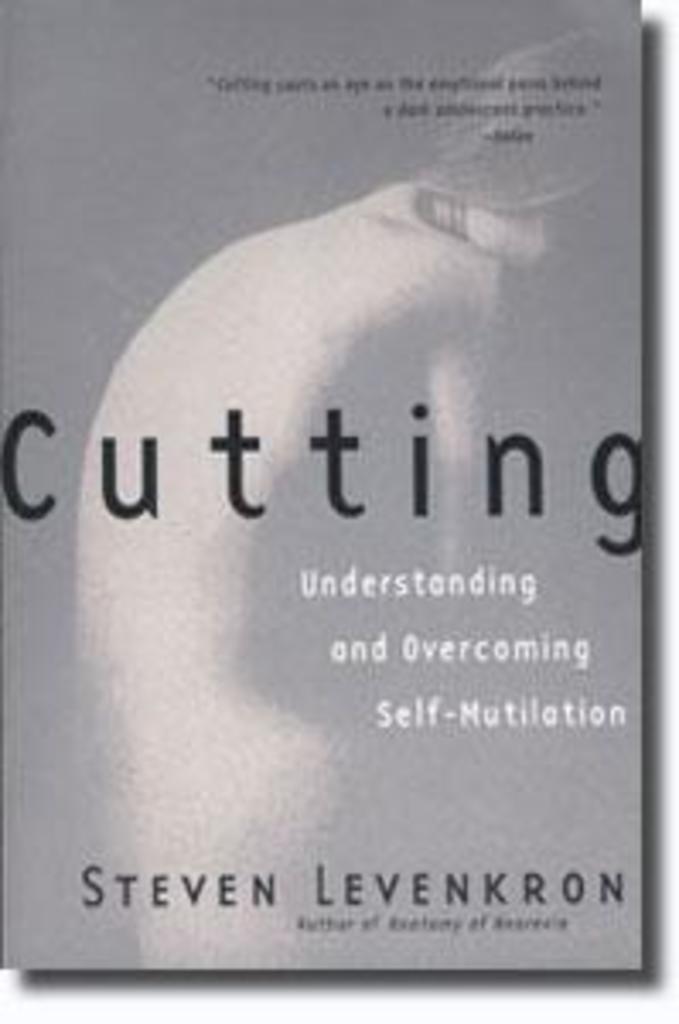What is this book called?
Provide a succinct answer. Cutting. What does this book help you understand?
Offer a very short reply. Self-mutilation. 